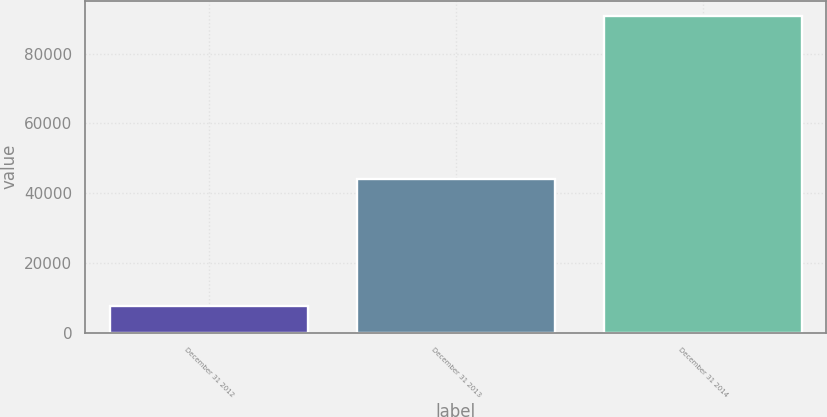Convert chart. <chart><loc_0><loc_0><loc_500><loc_500><bar_chart><fcel>December 31 2012<fcel>December 31 2013<fcel>December 31 2014<nl><fcel>7604<fcel>44106<fcel>90650<nl></chart> 